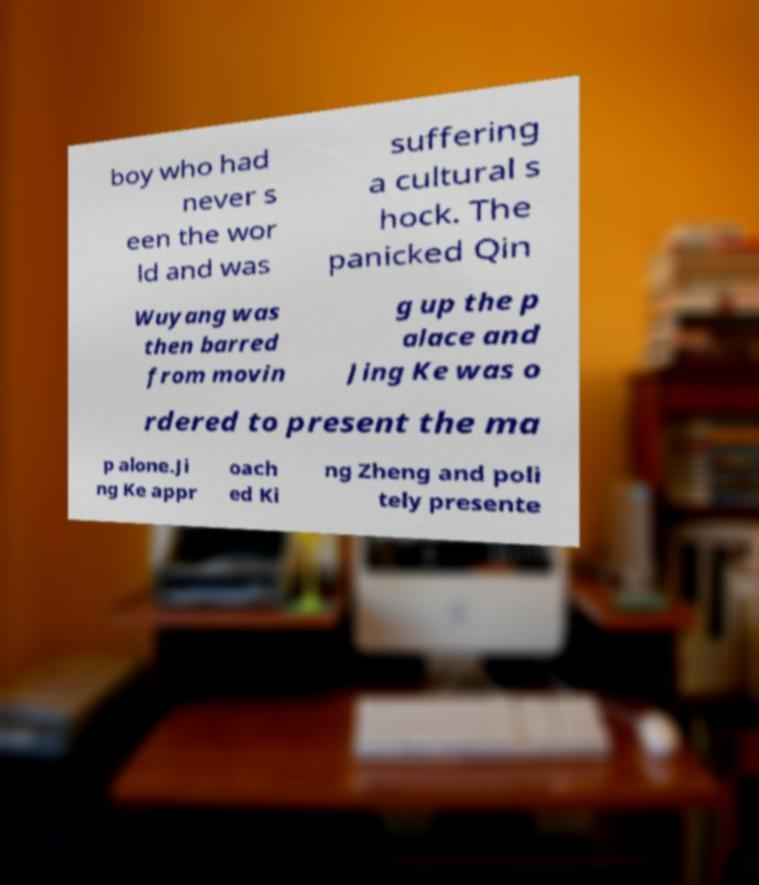I need the written content from this picture converted into text. Can you do that? boy who had never s een the wor ld and was suffering a cultural s hock. The panicked Qin Wuyang was then barred from movin g up the p alace and Jing Ke was o rdered to present the ma p alone.Ji ng Ke appr oach ed Ki ng Zheng and poli tely presente 